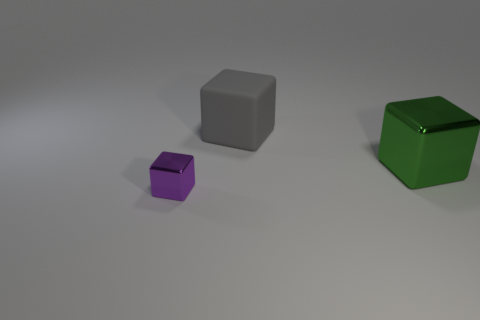Are there any other things that have the same size as the purple metal thing?
Provide a succinct answer. No. What number of things are tiny yellow metallic things or metallic cubes right of the purple metal cube?
Ensure brevity in your answer.  1. There is a shiny object that is behind the metallic cube on the left side of the metallic thing on the right side of the purple metallic object; what color is it?
Your answer should be very brief. Green. There is a shiny object on the left side of the big gray thing; how big is it?
Provide a succinct answer. Small. How many tiny things are either metal balls or rubber cubes?
Offer a terse response. 0. The thing that is behind the small metal thing and in front of the big gray rubber object is what color?
Provide a short and direct response. Green. Are there any purple metallic things that have the same shape as the big gray matte thing?
Make the answer very short. Yes. What is the material of the big gray cube?
Your response must be concise. Rubber. Are there any purple shiny cubes in front of the big rubber block?
Your response must be concise. Yes. Does the large green object have the same shape as the purple metal object?
Ensure brevity in your answer.  Yes. 